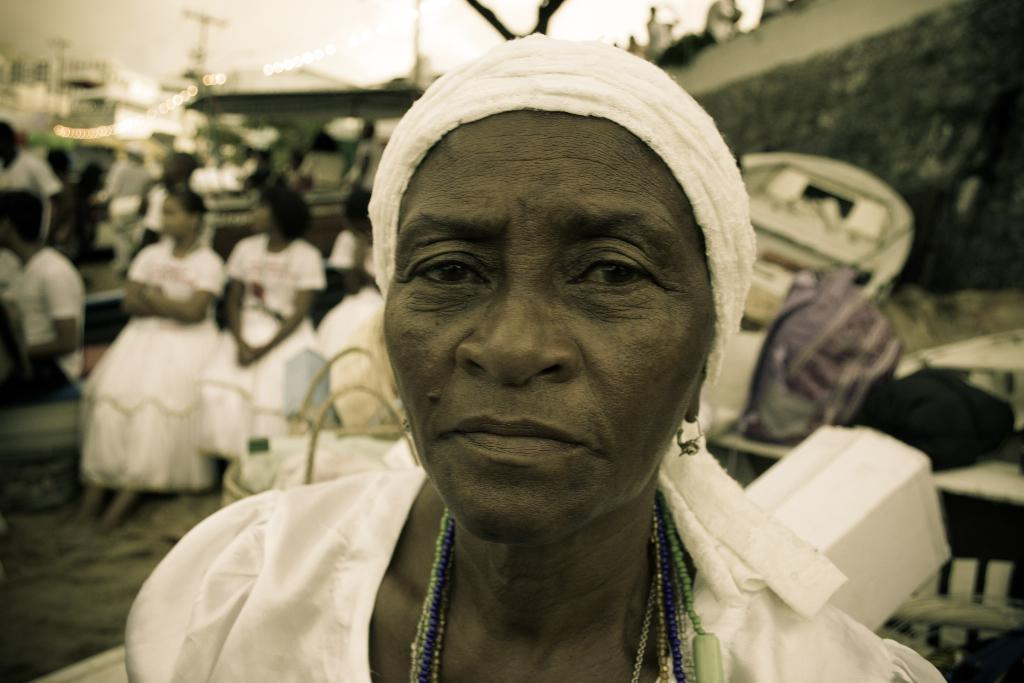What is the color scheme of the image? The image is black and white. Who is present in the image? There is a lady standing in the image. What can be seen in the background of the image? In the background of the image, there are people sitting on benches. How is the background of the image depicted? The background is blurred. What type of throat lozenge is the lady holding in the image? There is no throat lozenge present in the image, and the lady is not holding anything. 